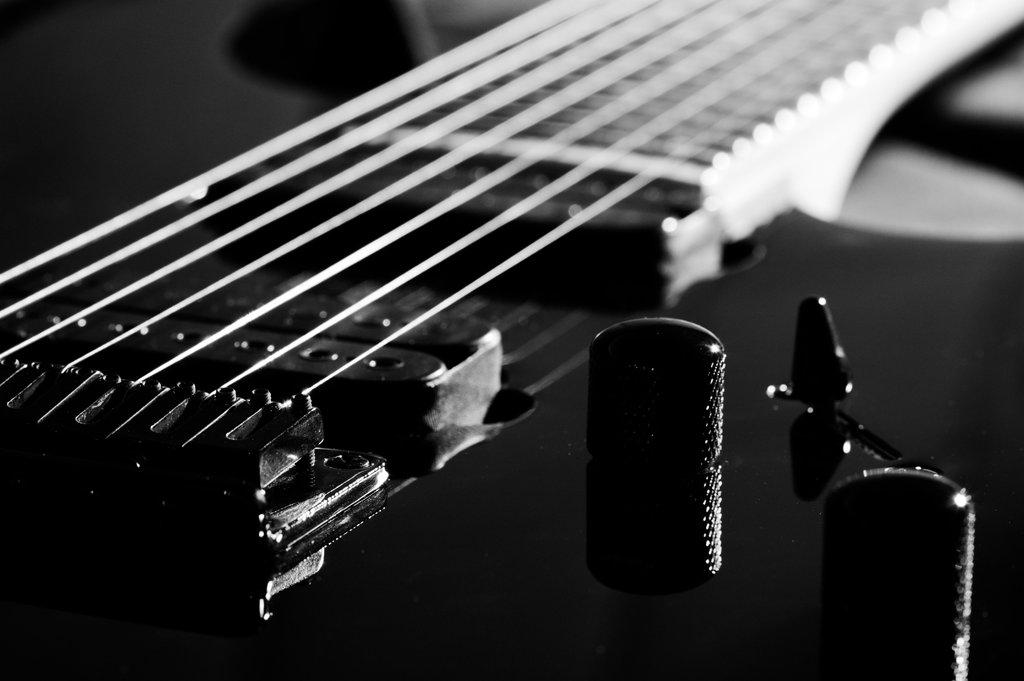What type of picture is in the image? The image contains a black and white picture. What is the main subject of the black and white picture? There is a guitar in the black and white picture. What is the color of the guitar? The guitar is black in color. Does the guitar have any specific features? Yes, the guitar has strings. Can you see a giraffe walking in the scene in the image? There is no giraffe or scene present in the image; it contains a black and white picture of a black guitar with strings. 